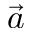<formula> <loc_0><loc_0><loc_500><loc_500>\vec { a }</formula> 